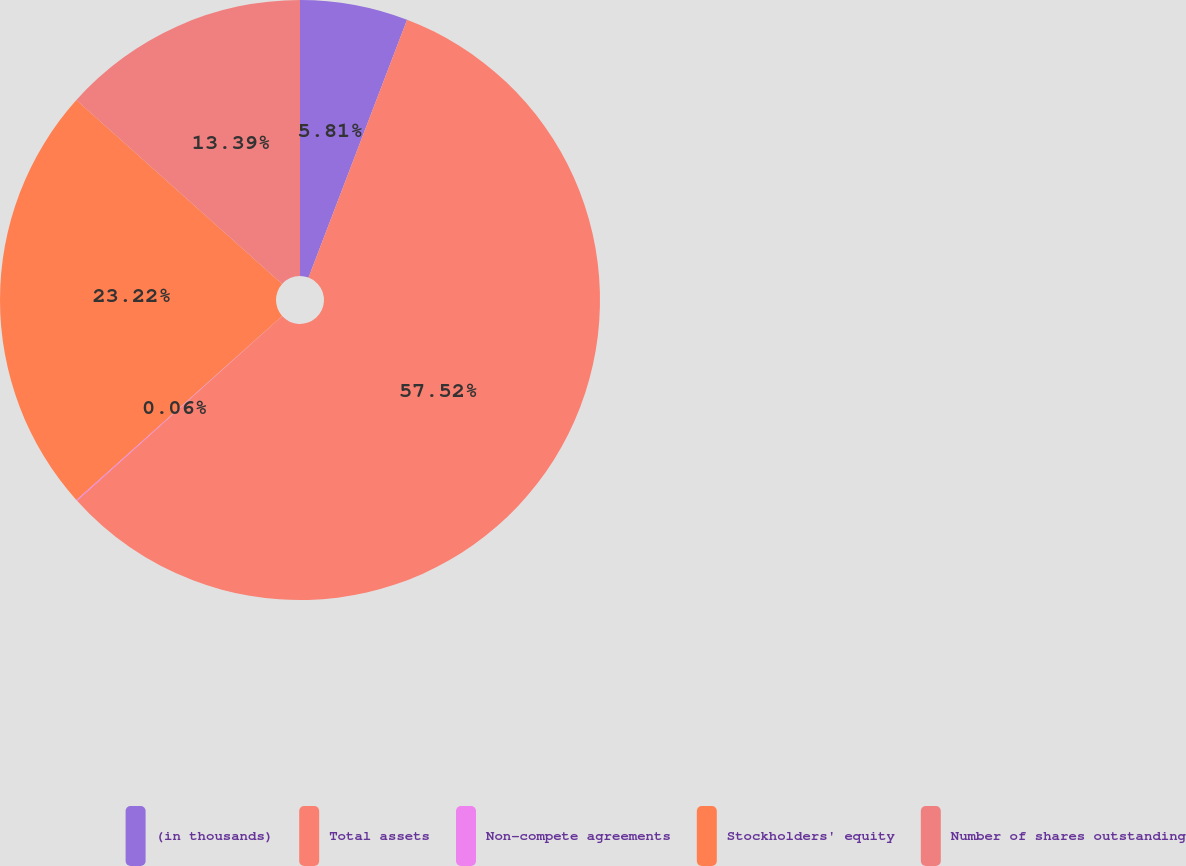Convert chart to OTSL. <chart><loc_0><loc_0><loc_500><loc_500><pie_chart><fcel>(in thousands)<fcel>Total assets<fcel>Non-compete agreements<fcel>Stockholders' equity<fcel>Number of shares outstanding<nl><fcel>5.81%<fcel>57.53%<fcel>0.06%<fcel>23.22%<fcel>13.39%<nl></chart> 